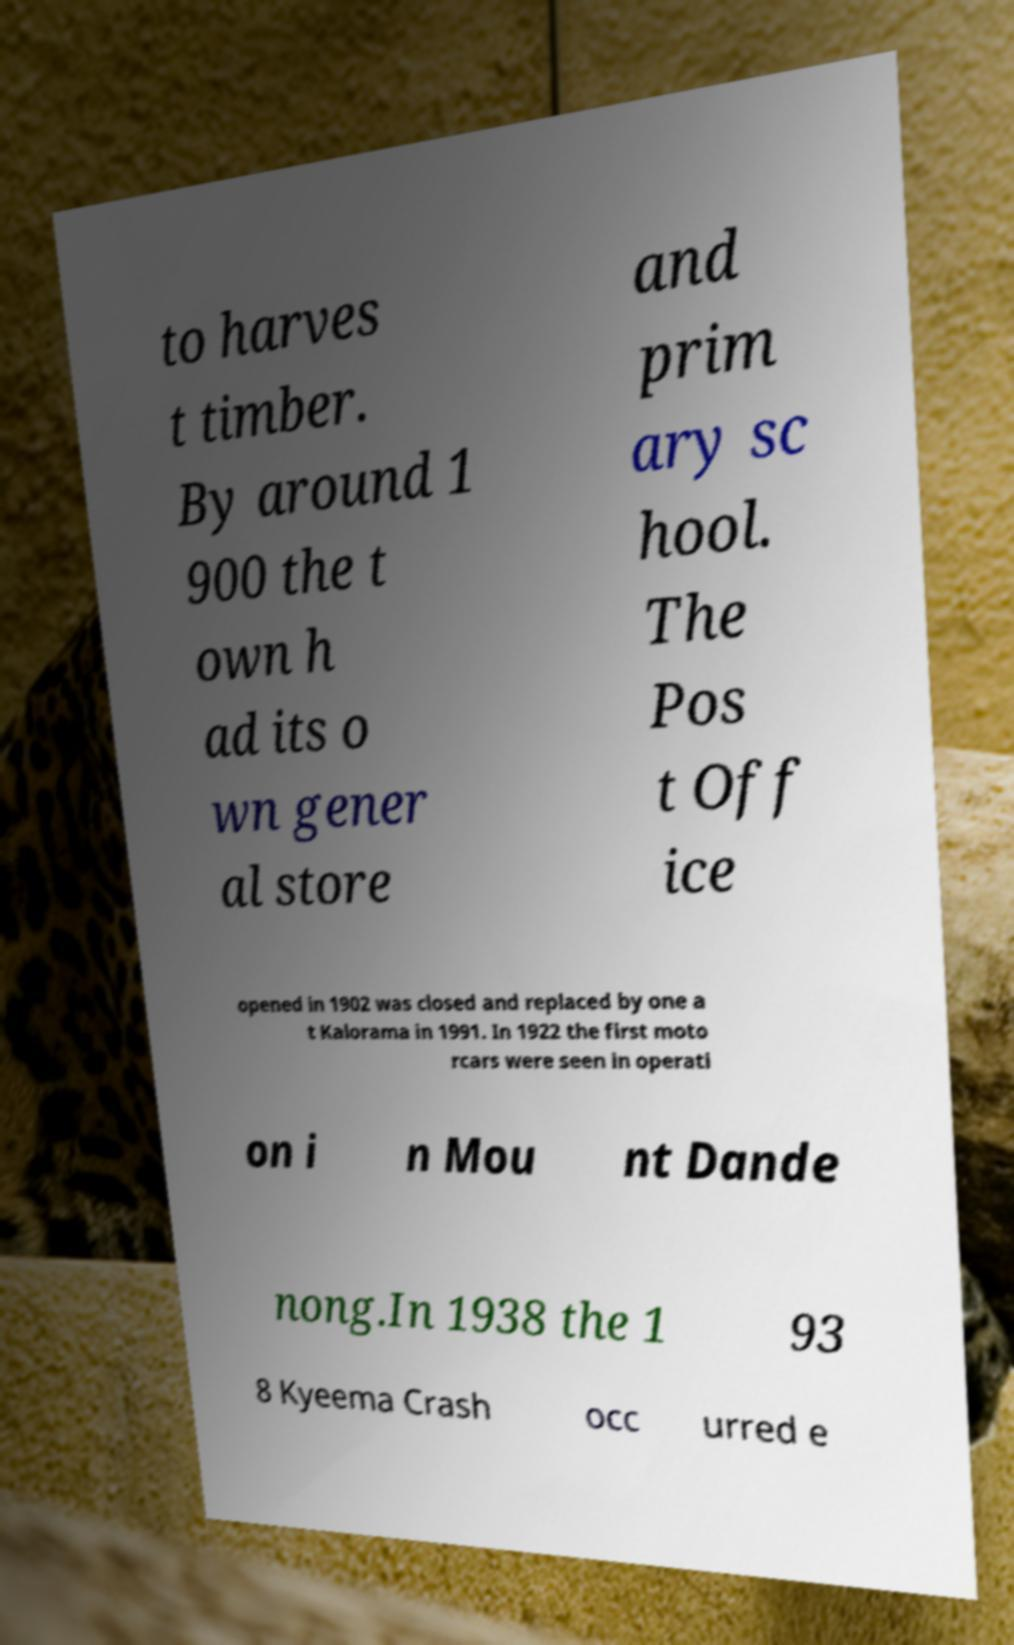Could you assist in decoding the text presented in this image and type it out clearly? to harves t timber. By around 1 900 the t own h ad its o wn gener al store and prim ary sc hool. The Pos t Off ice opened in 1902 was closed and replaced by one a t Kalorama in 1991. In 1922 the first moto rcars were seen in operati on i n Mou nt Dande nong.In 1938 the 1 93 8 Kyeema Crash occ urred e 